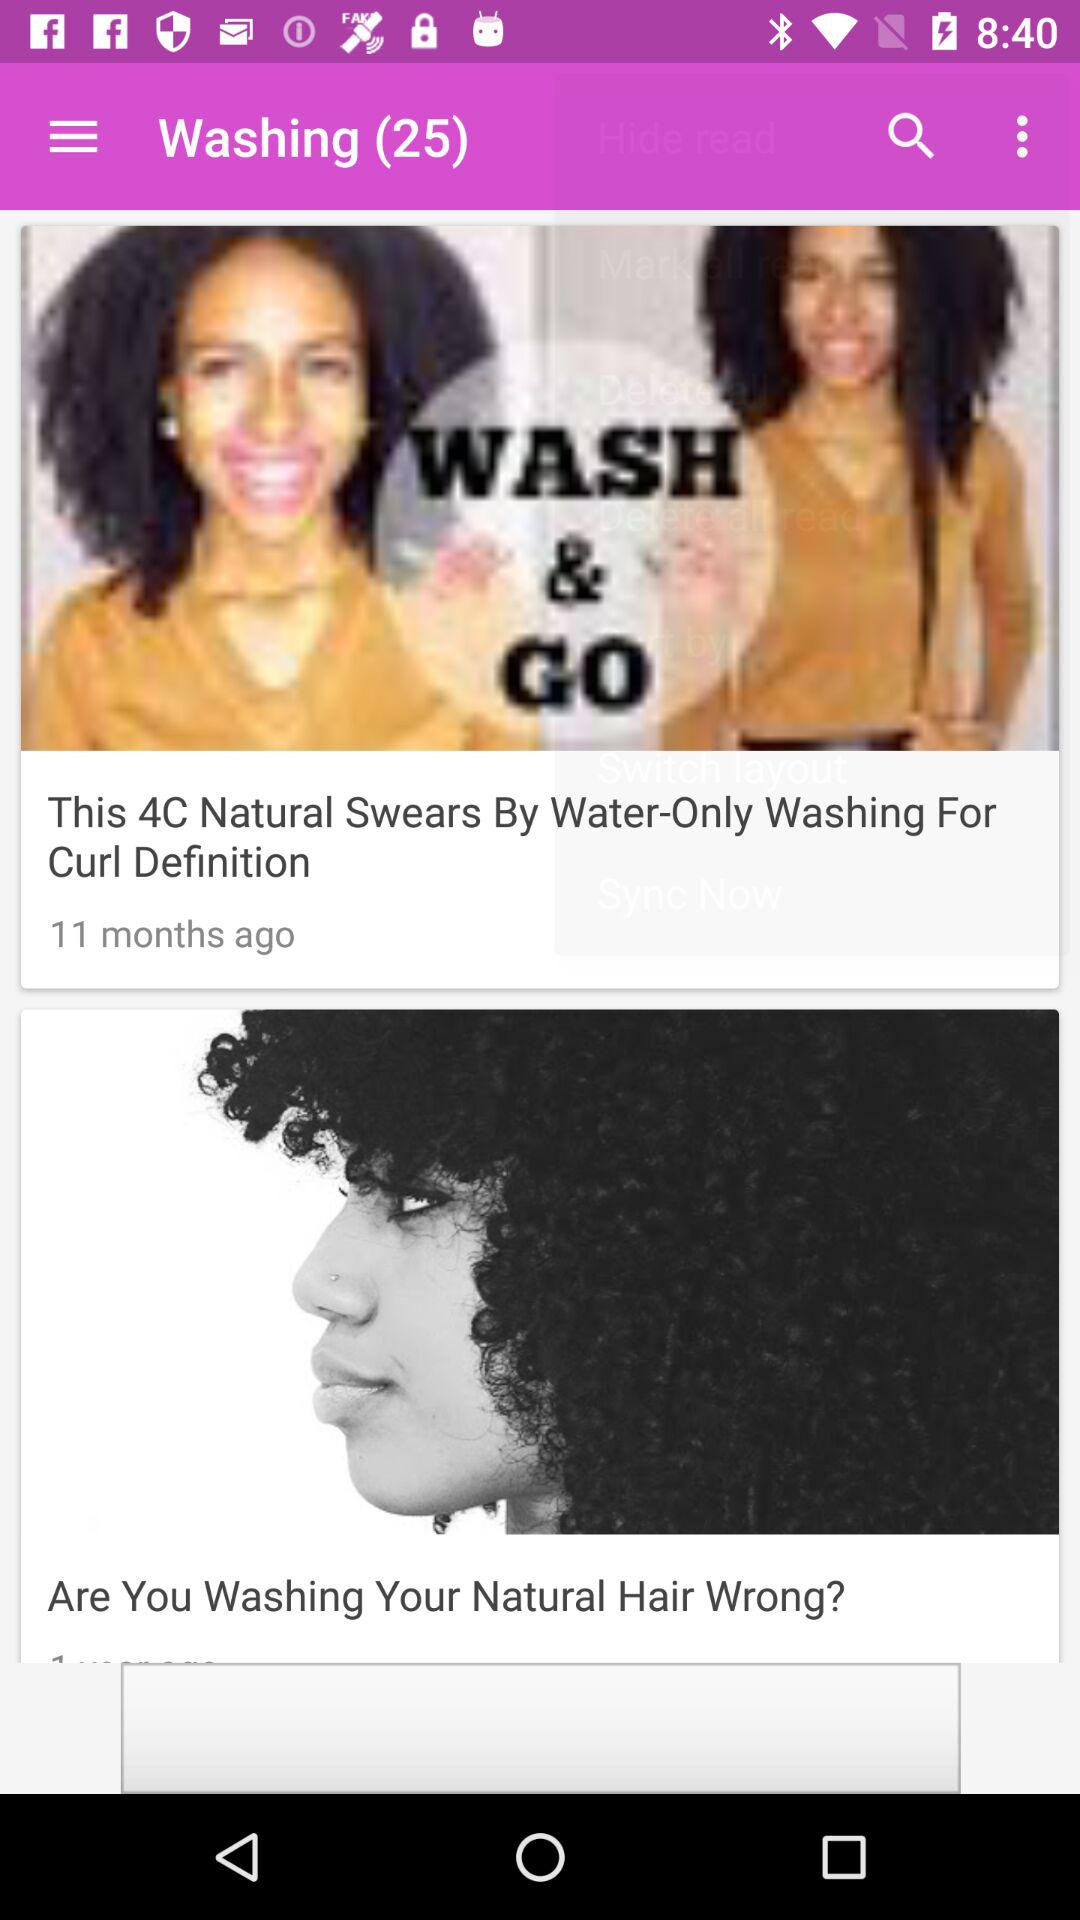What is the number shown with "Washing"? The number shown is 25. 